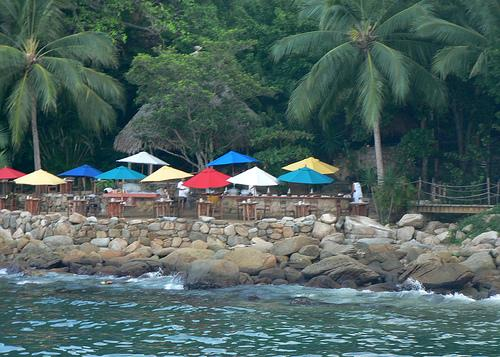What are the trees with one thin trunk called?

Choices:
A) willow trees
B) birch trees
C) palm trees
D) pine trees palm trees 